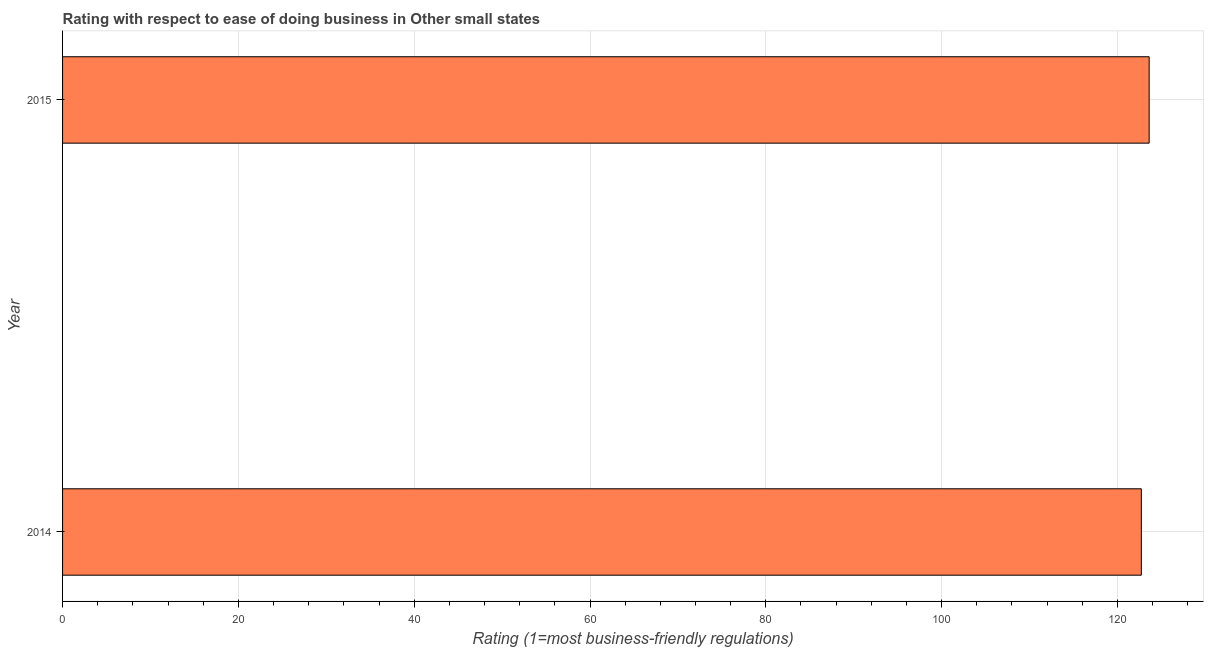Does the graph contain any zero values?
Keep it short and to the point. No. What is the title of the graph?
Keep it short and to the point. Rating with respect to ease of doing business in Other small states. What is the label or title of the X-axis?
Offer a very short reply. Rating (1=most business-friendly regulations). What is the ease of doing business index in 2015?
Ensure brevity in your answer.  123.61. Across all years, what is the maximum ease of doing business index?
Your response must be concise. 123.61. Across all years, what is the minimum ease of doing business index?
Your response must be concise. 122.72. In which year was the ease of doing business index maximum?
Ensure brevity in your answer.  2015. In which year was the ease of doing business index minimum?
Offer a terse response. 2014. What is the sum of the ease of doing business index?
Offer a very short reply. 246.33. What is the difference between the ease of doing business index in 2014 and 2015?
Your response must be concise. -0.89. What is the average ease of doing business index per year?
Provide a short and direct response. 123.17. What is the median ease of doing business index?
Your response must be concise. 123.17. In how many years, is the ease of doing business index greater than 116 ?
Provide a short and direct response. 2. Is the ease of doing business index in 2014 less than that in 2015?
Ensure brevity in your answer.  Yes. How many bars are there?
Offer a very short reply. 2. Are all the bars in the graph horizontal?
Provide a short and direct response. Yes. What is the difference between two consecutive major ticks on the X-axis?
Offer a very short reply. 20. Are the values on the major ticks of X-axis written in scientific E-notation?
Your answer should be compact. No. What is the Rating (1=most business-friendly regulations) of 2014?
Your response must be concise. 122.72. What is the Rating (1=most business-friendly regulations) of 2015?
Offer a very short reply. 123.61. What is the difference between the Rating (1=most business-friendly regulations) in 2014 and 2015?
Offer a terse response. -0.89. 